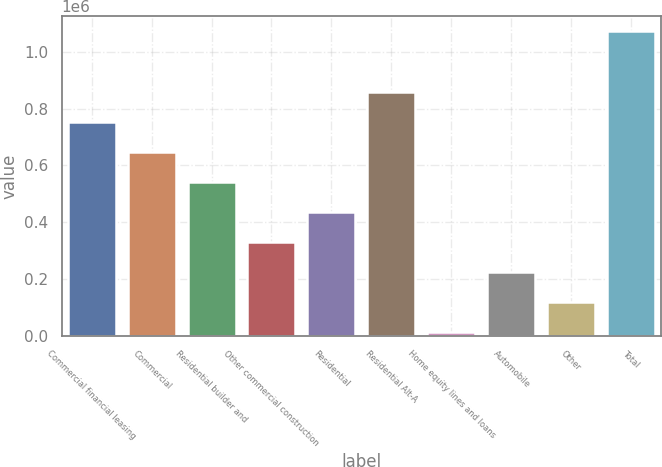Convert chart to OTSL. <chart><loc_0><loc_0><loc_500><loc_500><bar_chart><fcel>Commercial financial leasing<fcel>Commercial<fcel>Residential builder and<fcel>Other commercial construction<fcel>Residential<fcel>Residential Alt-A<fcel>Home equity lines and loans<fcel>Automobile<fcel>Other<fcel>Total<nl><fcel>754126<fcel>648160<fcel>542193<fcel>330260<fcel>436226<fcel>860093<fcel>12360<fcel>224293<fcel>118327<fcel>1.07203e+06<nl></chart> 